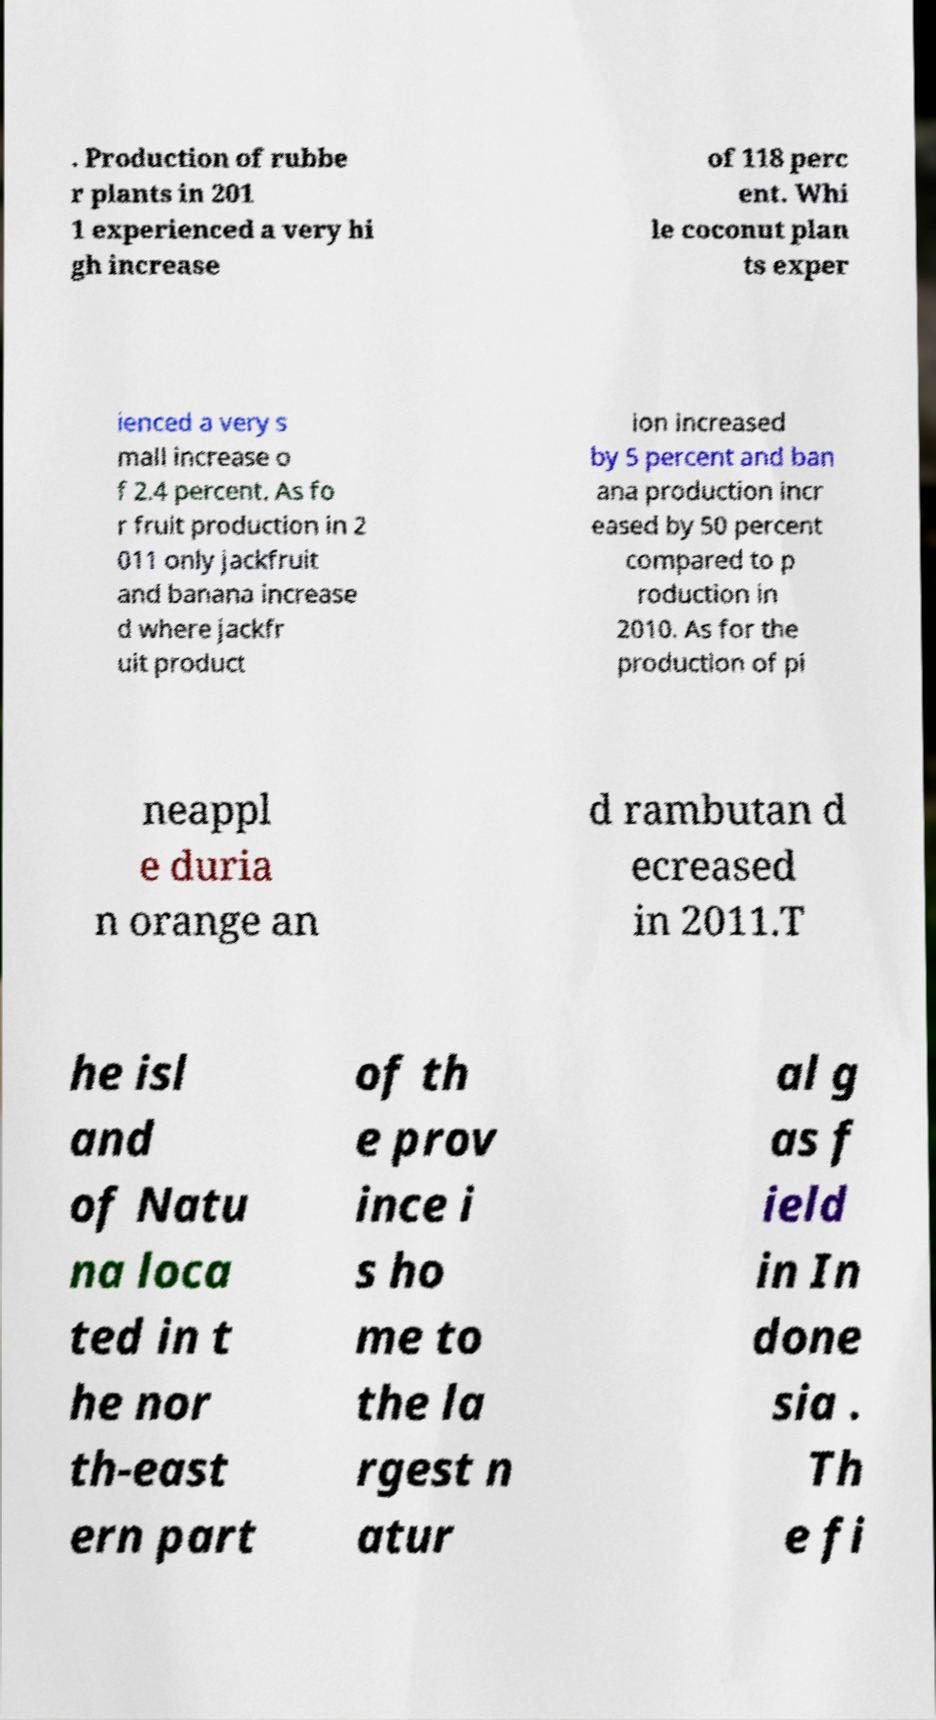Could you assist in decoding the text presented in this image and type it out clearly? . Production of rubbe r plants in 201 1 experienced a very hi gh increase of 118 perc ent. Whi le coconut plan ts exper ienced a very s mall increase o f 2.4 percent. As fo r fruit production in 2 011 only jackfruit and banana increase d where jackfr uit product ion increased by 5 percent and ban ana production incr eased by 50 percent compared to p roduction in 2010. As for the production of pi neappl e duria n orange an d rambutan d ecreased in 2011.T he isl and of Natu na loca ted in t he nor th-east ern part of th e prov ince i s ho me to the la rgest n atur al g as f ield in In done sia . Th e fi 